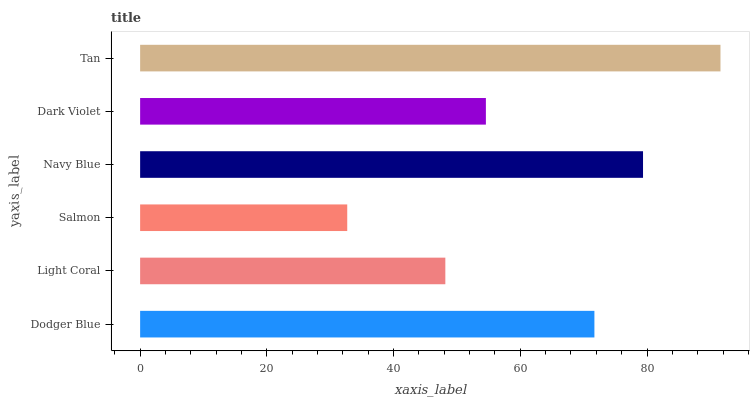Is Salmon the minimum?
Answer yes or no. Yes. Is Tan the maximum?
Answer yes or no. Yes. Is Light Coral the minimum?
Answer yes or no. No. Is Light Coral the maximum?
Answer yes or no. No. Is Dodger Blue greater than Light Coral?
Answer yes or no. Yes. Is Light Coral less than Dodger Blue?
Answer yes or no. Yes. Is Light Coral greater than Dodger Blue?
Answer yes or no. No. Is Dodger Blue less than Light Coral?
Answer yes or no. No. Is Dodger Blue the high median?
Answer yes or no. Yes. Is Dark Violet the low median?
Answer yes or no. Yes. Is Dark Violet the high median?
Answer yes or no. No. Is Salmon the low median?
Answer yes or no. No. 